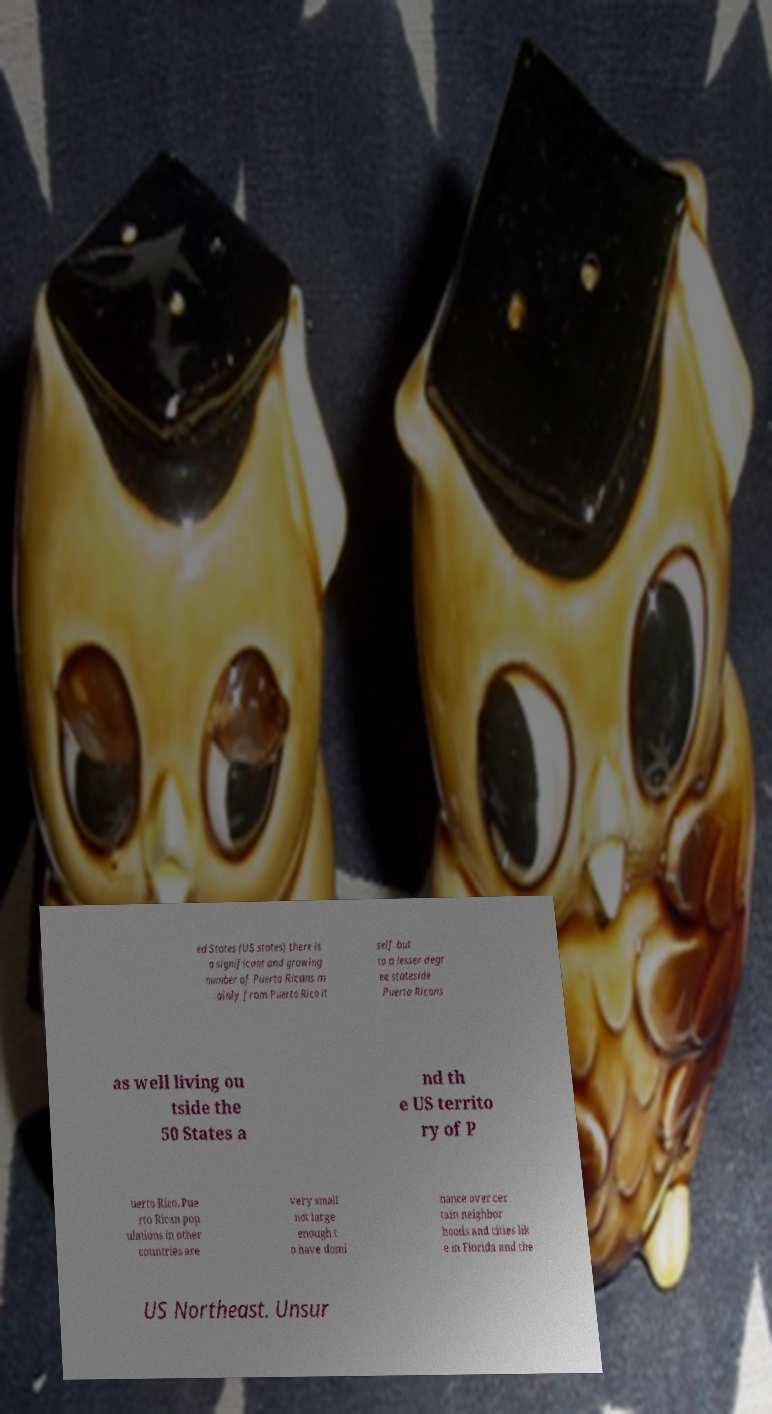Could you extract and type out the text from this image? ed States (US states) there is a significant and growing number of Puerto Ricans m ainly from Puerto Rico it self but to a lesser degr ee stateside Puerto Ricans as well living ou tside the 50 States a nd th e US territo ry of P uerto Rico. Pue rto Rican pop ulations in other countries are very small not large enough t o have domi nance over cer tain neighbor hoods and cities lik e in Florida and the US Northeast. Unsur 